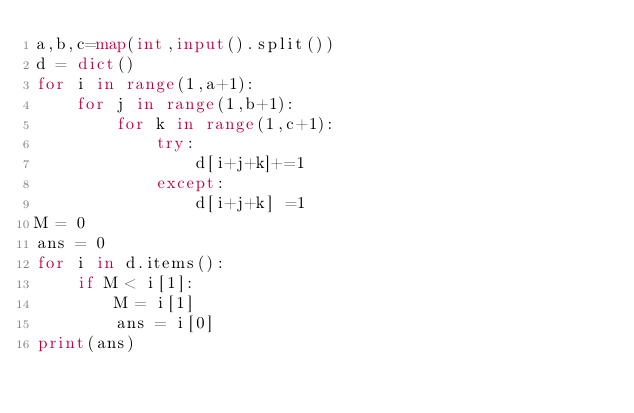<code> <loc_0><loc_0><loc_500><loc_500><_Python_>a,b,c=map(int,input().split())
d = dict()
for i in range(1,a+1):
    for j in range(1,b+1):
        for k in range(1,c+1):
            try:
                d[i+j+k]+=1
            except:
                d[i+j+k] =1
M = 0
ans = 0
for i in d.items():
    if M < i[1]:
        M = i[1]
        ans = i[0]
print(ans)</code> 